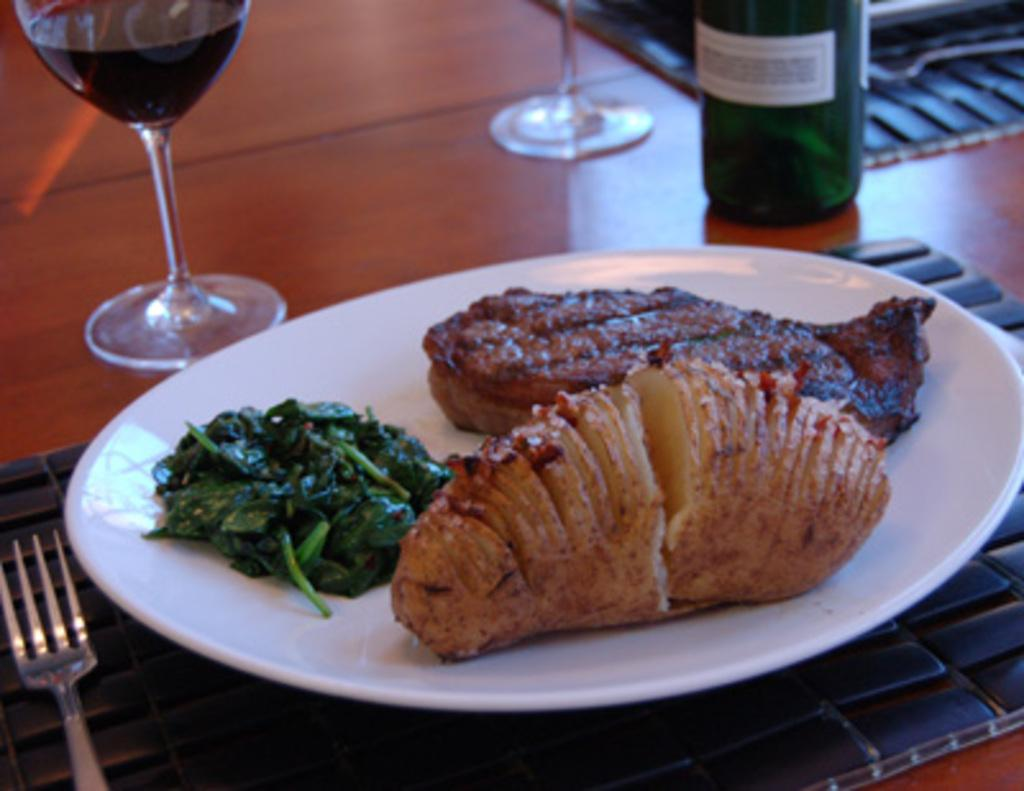What is on the plate in the image? There is food in a plate in the image. What can be seen besides the plate in the image? There is a beverage bottle and glass tumblers in the image. What utensil is present in the image? There is a fork in the image. Where are all these items located? All of these items are placed on a table. What type of plants are growing on the crown in the image? There is no crown or plants present in the image. 